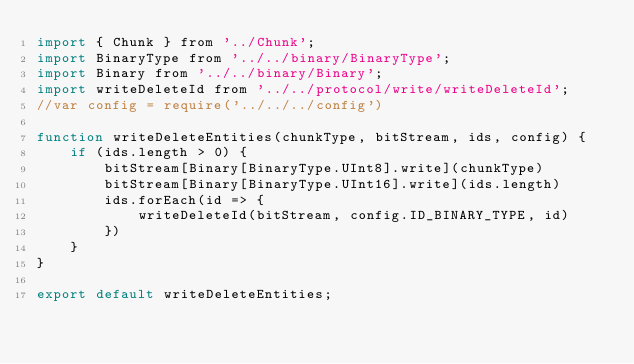<code> <loc_0><loc_0><loc_500><loc_500><_JavaScript_>import { Chunk } from '../Chunk';
import BinaryType from '../../binary/BinaryType';
import Binary from '../../binary/Binary';
import writeDeleteId from '../../protocol/write/writeDeleteId';
//var config = require('../../../config')

function writeDeleteEntities(chunkType, bitStream, ids, config) {
    if (ids.length > 0) {
        bitStream[Binary[BinaryType.UInt8].write](chunkType)  
        bitStream[Binary[BinaryType.UInt16].write](ids.length)        
        ids.forEach(id => {
            writeDeleteId(bitStream, config.ID_BINARY_TYPE, id)
        })
    }
}

export default writeDeleteEntities;</code> 